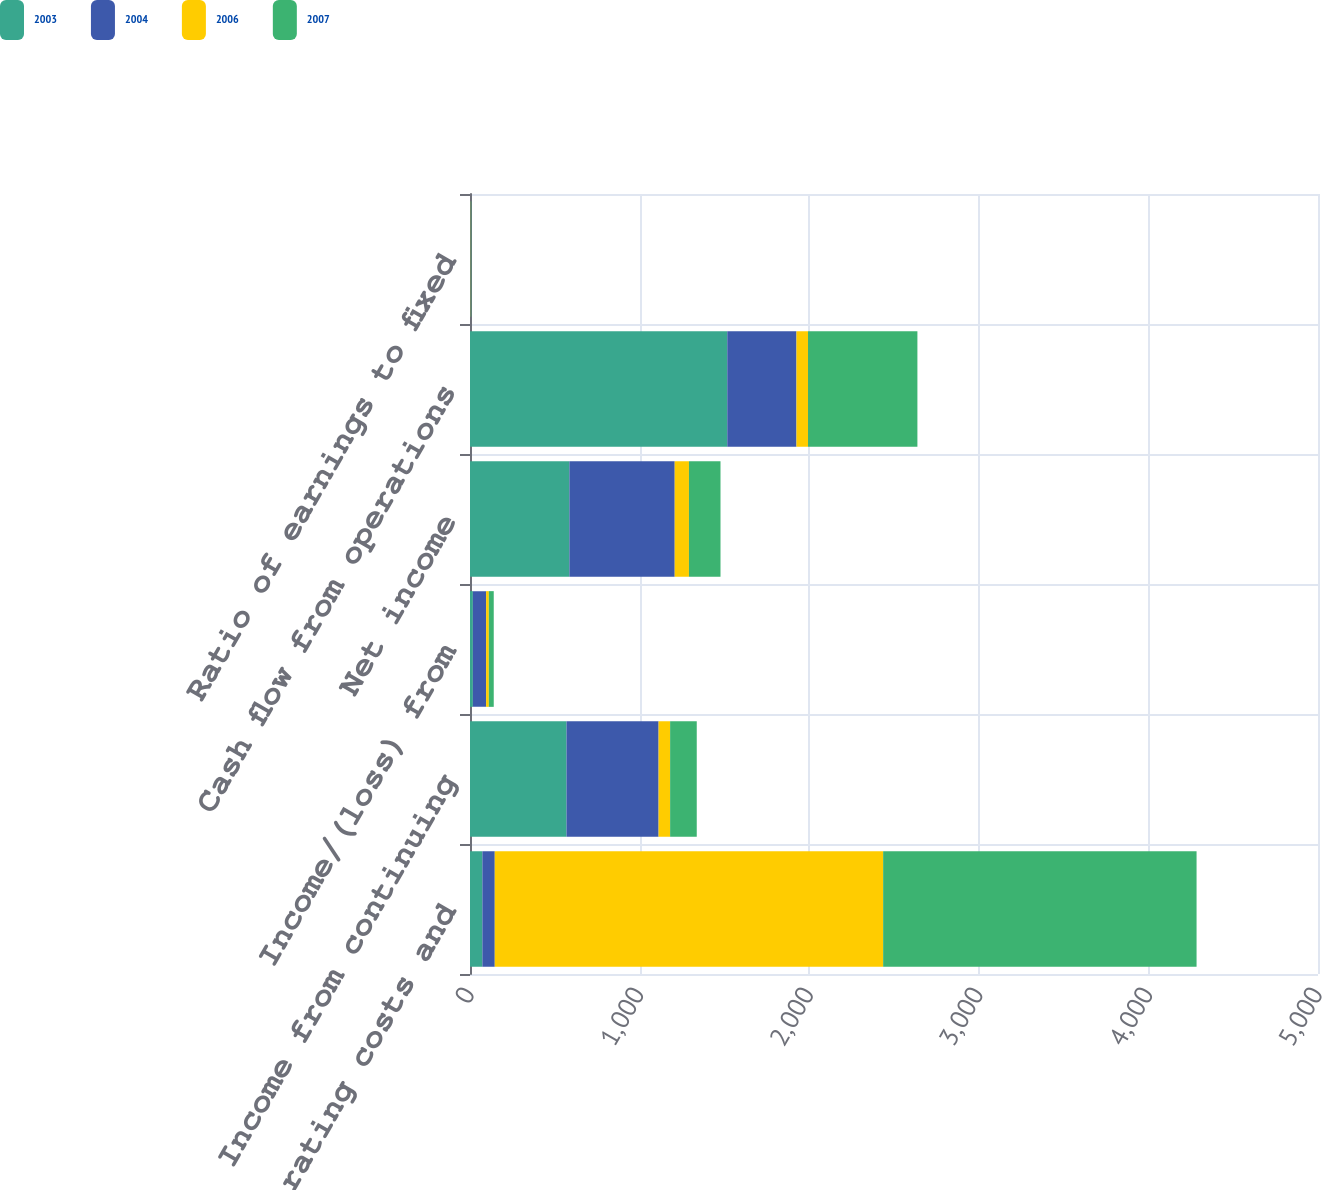Convert chart to OTSL. <chart><loc_0><loc_0><loc_500><loc_500><stacked_bar_chart><ecel><fcel>Total operating costs and<fcel>Income from continuing<fcel>Income/(loss) from<fcel>Net income<fcel>Cash flow from operations<fcel>Ratio of earnings to fixed<nl><fcel>2003<fcel>73<fcel>569<fcel>17<fcel>586<fcel>1517<fcel>2.03<nl><fcel>2004<fcel>73<fcel>543<fcel>78<fcel>621<fcel>408<fcel>2.09<nl><fcel>2006<fcel>2290<fcel>68<fcel>16<fcel>84<fcel>68<fcel>1.3<nl><fcel>2007<fcel>1848<fcel>157<fcel>29<fcel>186<fcel>645<fcel>1.92<nl></chart> 